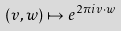<formula> <loc_0><loc_0><loc_500><loc_500>( v , w ) \mapsto e ^ { 2 \pi { i } { v } \cdot { w } }</formula> 